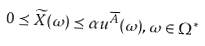<formula> <loc_0><loc_0><loc_500><loc_500>0 \preceq \widetilde { X } ( \omega ) \preceq \alpha u ^ { \overline { A } } ( \omega ) , \omega \in \Omega ^ { \ast }</formula> 